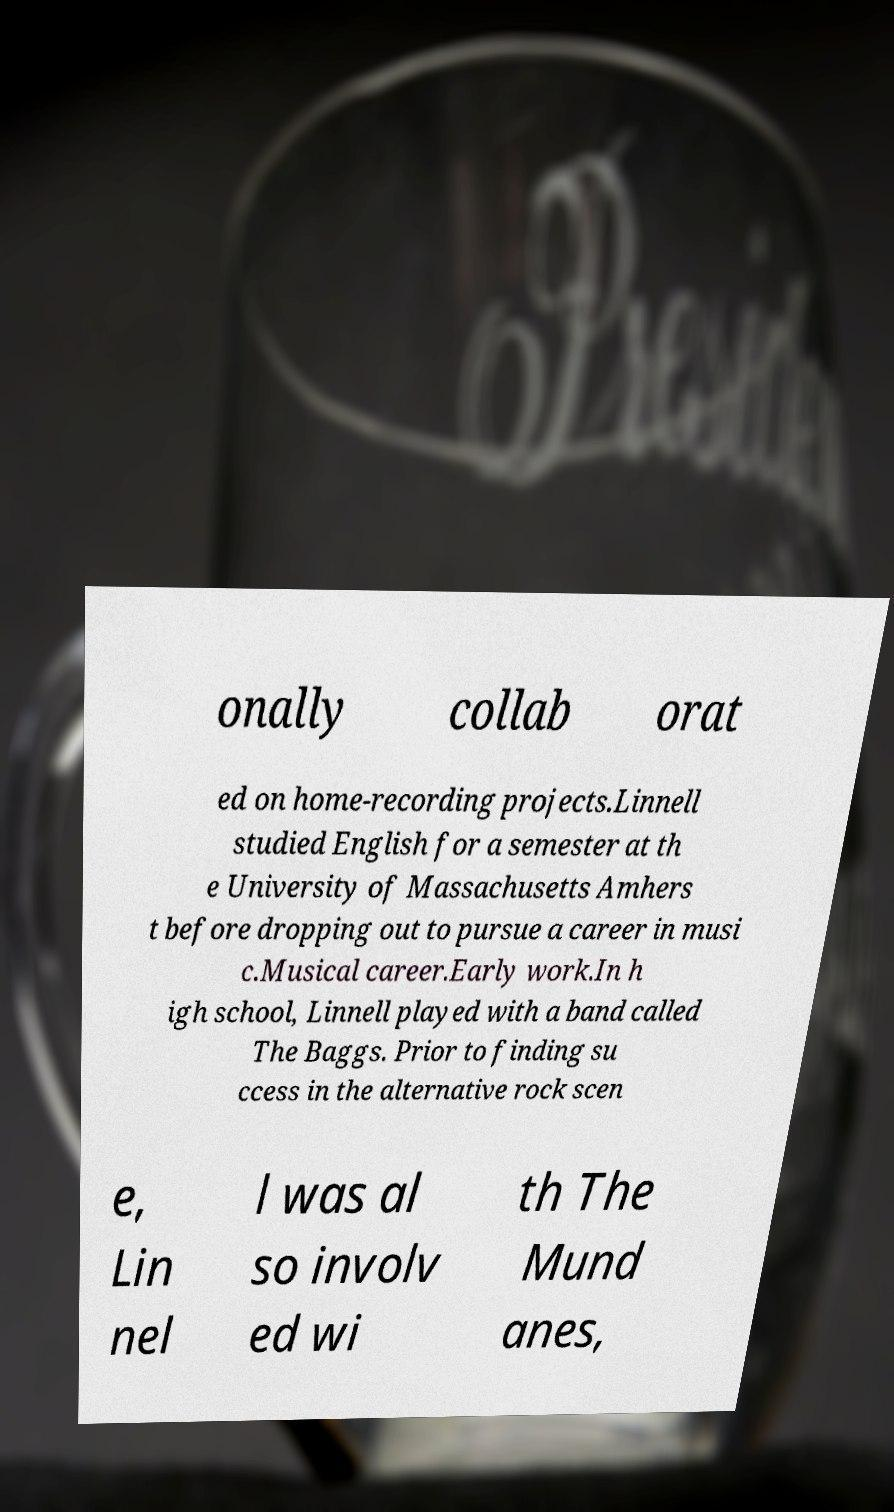Can you accurately transcribe the text from the provided image for me? onally collab orat ed on home-recording projects.Linnell studied English for a semester at th e University of Massachusetts Amhers t before dropping out to pursue a career in musi c.Musical career.Early work.In h igh school, Linnell played with a band called The Baggs. Prior to finding su ccess in the alternative rock scen e, Lin nel l was al so involv ed wi th The Mund anes, 